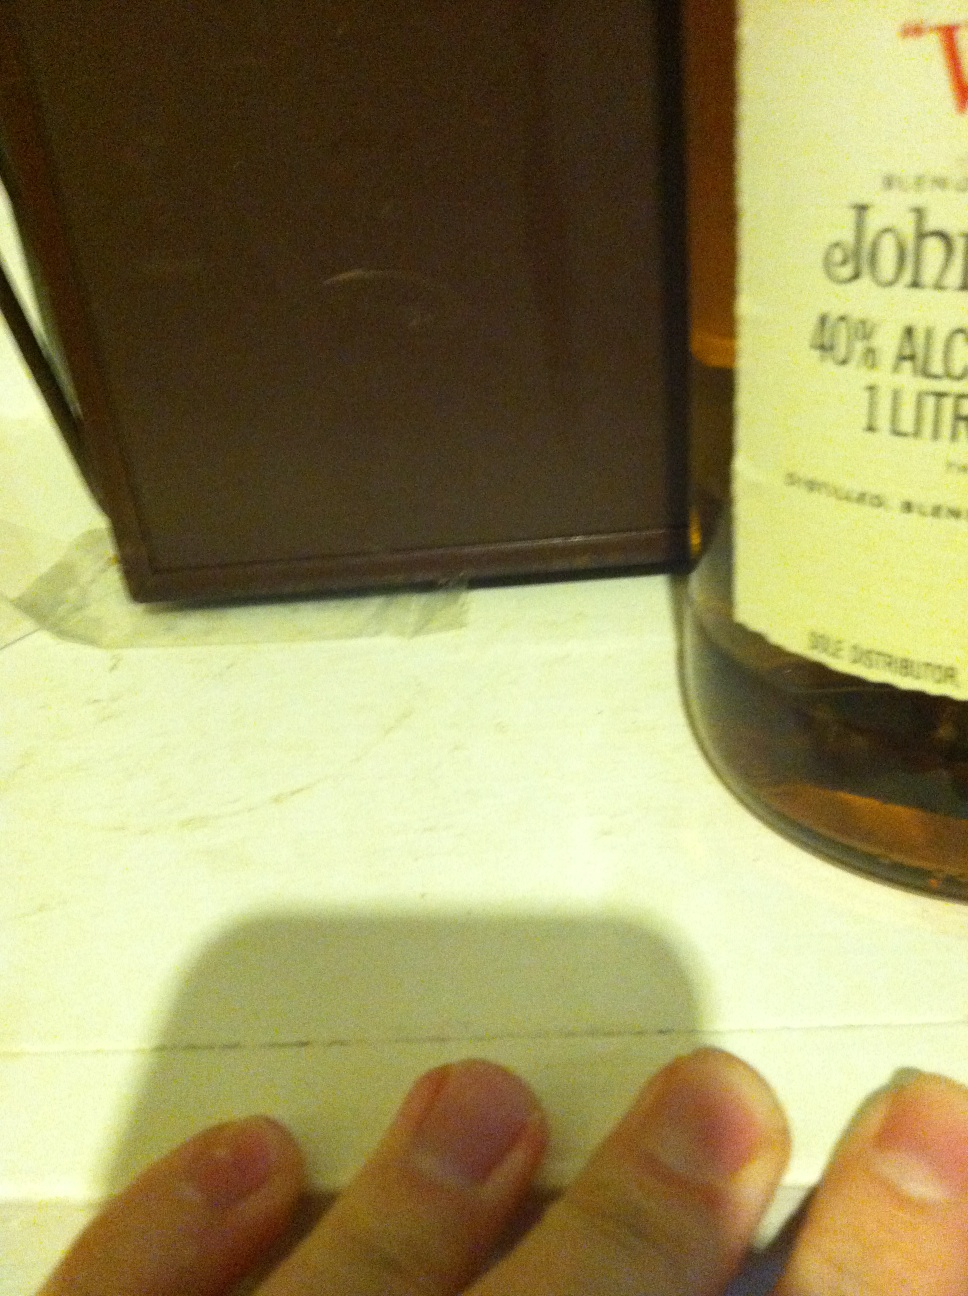Describe a short realistic scenario where this whisky might be shared in a single sentence. A father and son sit down on the porch, sharing a glass of this whisky as they talk about life and old family stories. 